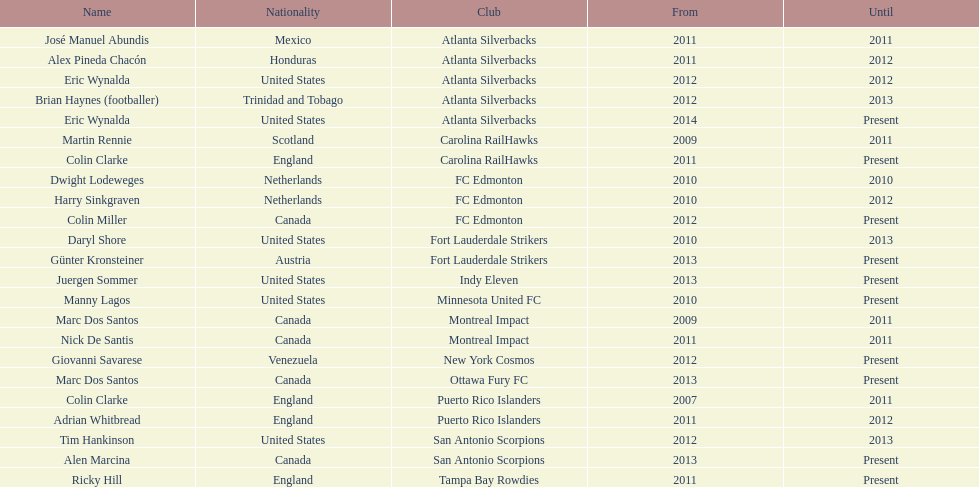Who was the final coach for the san antonio scorpions? Alen Marcina. 